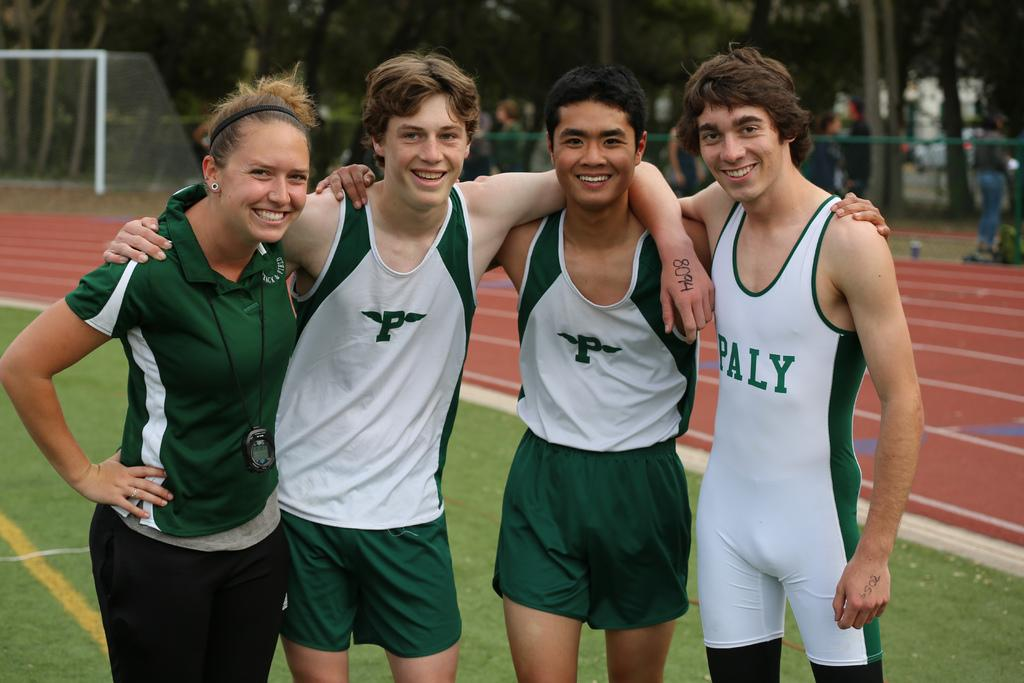<image>
Render a clear and concise summary of the photo. a few friends that are athletes wearing Paly jerseys 